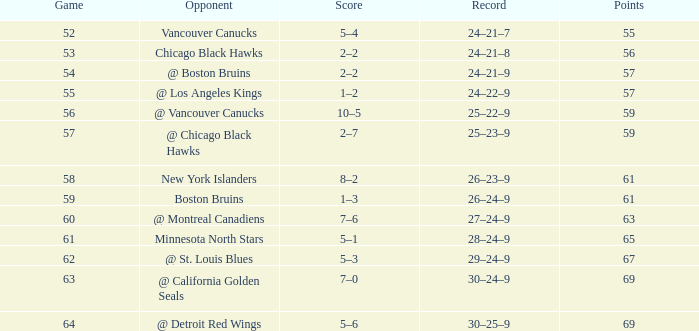How many february games had a record of 29–24–9? 20.0. 